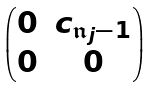<formula> <loc_0><loc_0><loc_500><loc_500>\begin{pmatrix} 0 & c _ { \mathfrak { n } _ { j } - 1 } \\ 0 & 0 \\ \end{pmatrix}</formula> 